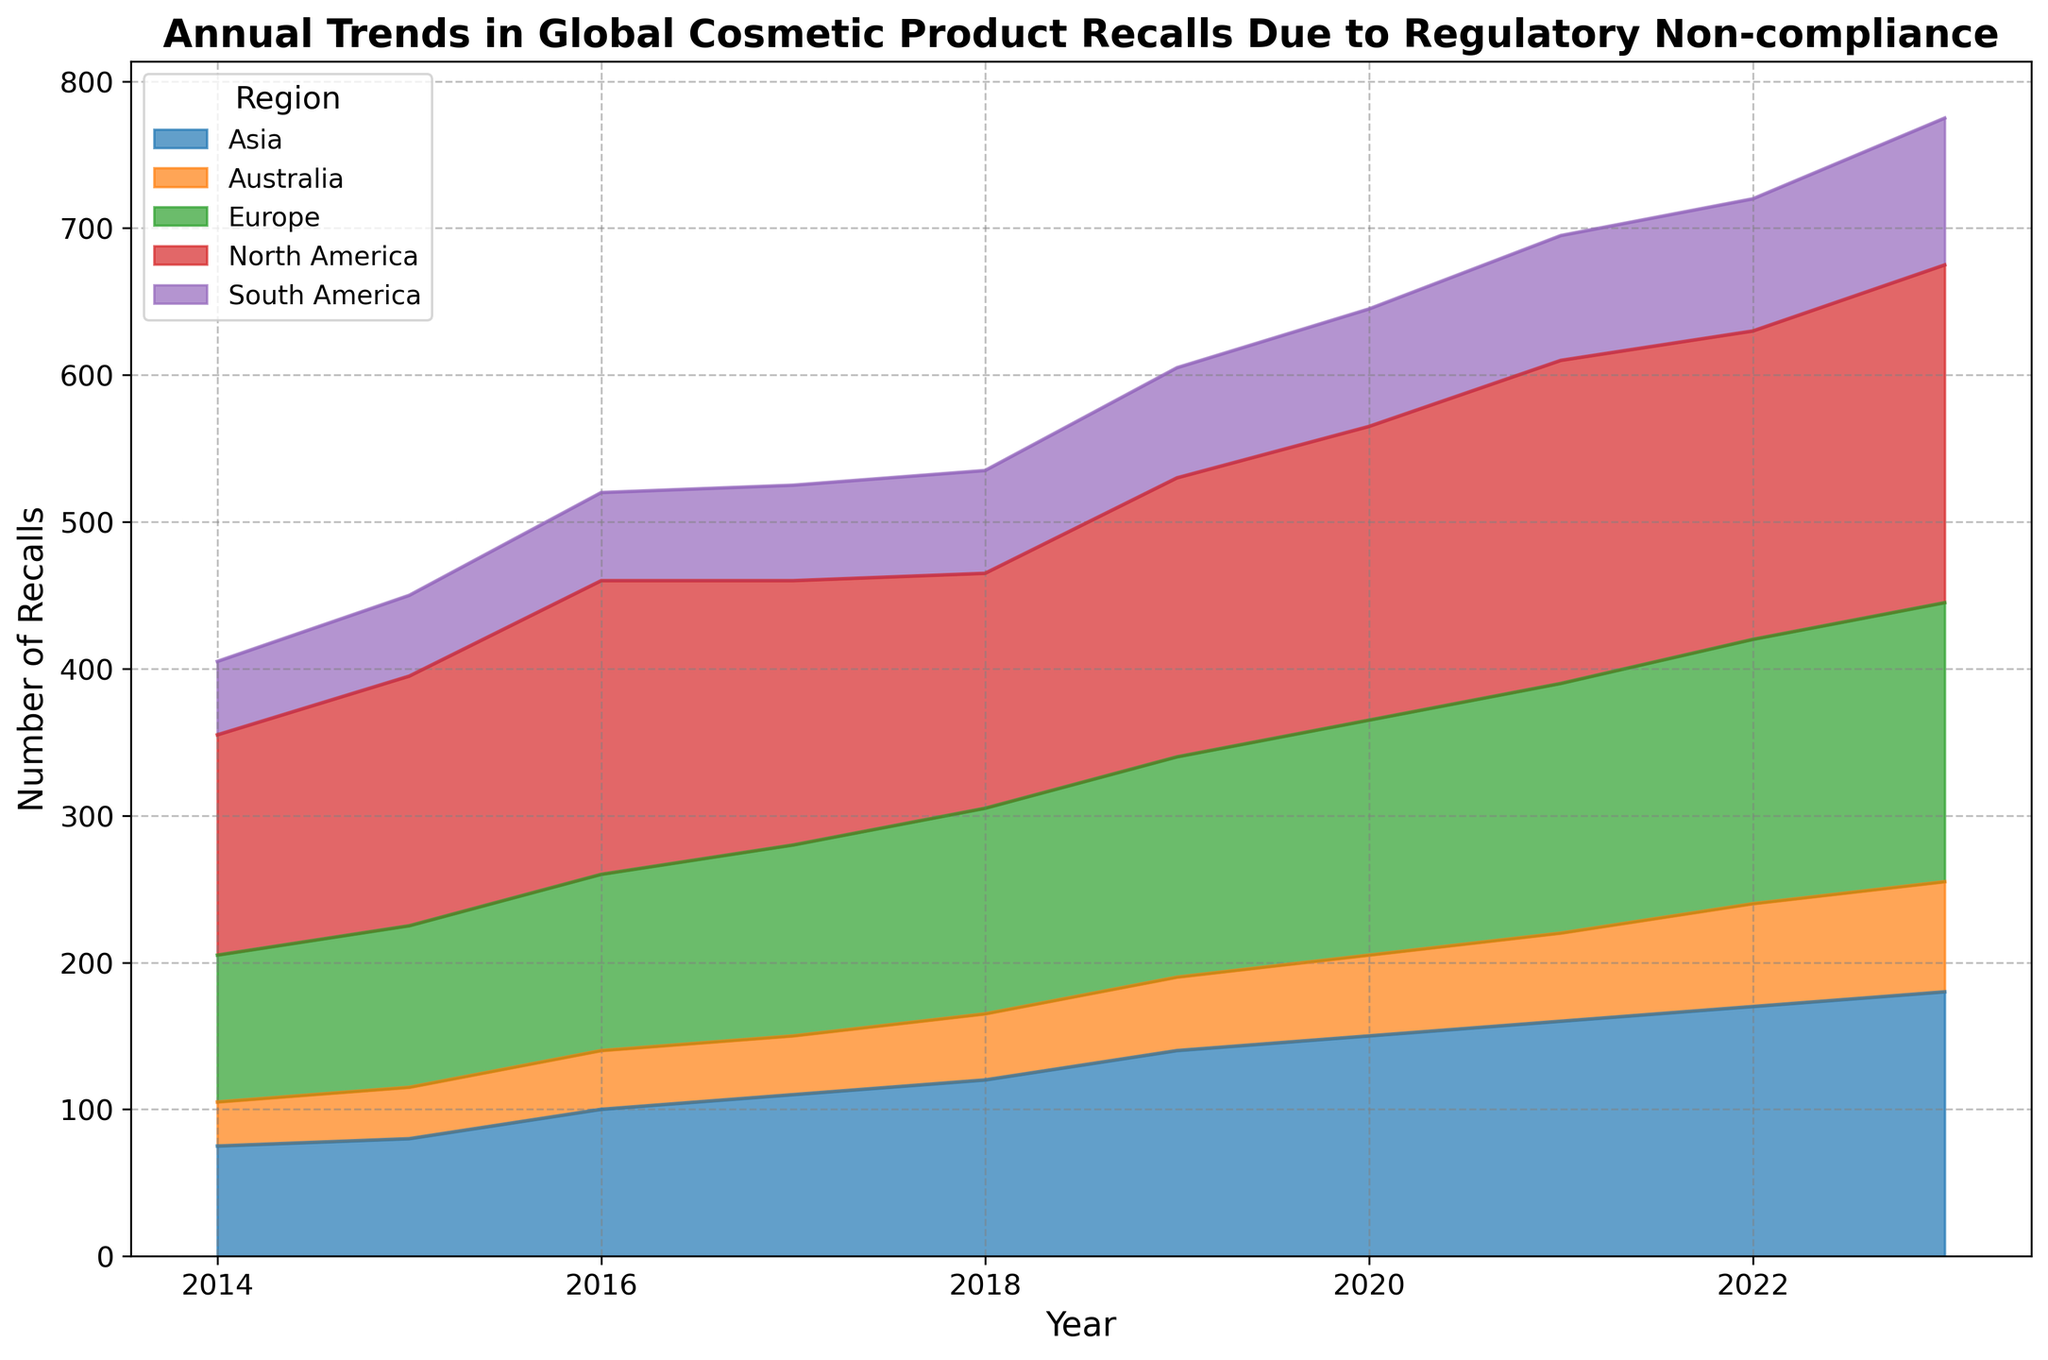When did North America experience the highest number of recalls? To determine the year with the highest number of recalls for North America, look at the height of the colored region corresponding to North America for each year and identify the peak. This occurs in 2023, noticeably higher compared to other years.
Answer: 2023 Which region saw the biggest increase in recalls from 2014 to 2023? To find this, calculate the difference in recalls between 2014 and 2023 for each region. For North America, it increased by 80 (230-150), Europe by 90 (190-100), Asia by 105 (180-75), South America by 50 (100-50), and Australia by 45 (75-30). Asia saw the biggest increase, 105.
Answer: Asia Across all regions, what is the combined total number of recalls in 2020? Sum the number of recalls for each region in 2020. North America: 200, Europe: 160, Asia: 150, South America: 80, Australia: 55. So, 200 + 160 + 150 + 80 + 55 = 645.
Answer: 645 Which region had the smallest number of recalls in 2018? Compare the values for 2018: North America (160), Europe (140), Asia (120), South America (70), Australia (45). Australia has the smallest value.
Answer: Australia What is the general trend for Europe in the number of recalls from 2014 to 2023? Observe the color band for Europe and notice its height's change over the years. The band generally increases from 100 in 2014 to 190 in 2023, showing a rising trend.
Answer: Increasing How did the number of recalls in South America change from 2016 to 2018? Compare the 2016 (60 recalls) and 2018 (70 recalls) values for South America. The number increased by 10 (70-60).
Answer: Increased What is the total number of recalls for Australia from 2014 to 2023? Sum the annual recalls for Australia over the years: 30+35+40+40+45+50+55+60+70+75 = 500.
Answer: 500 In which year did Asia experience the largest annual increase in recalls? Calculate the annual differences for Asia: 2015 (+5), 2016 (+20), 2017 (+10), 2018 (+10), 2019 (+20), 2020 (+10), 2021 (+10), 2022 (+10), 2023 (+10). The largest increase is from 2015 to 2016 (+20) and 2018 to 2019 (+20).
Answer: 2016 or 2019 Which two regions have the closest number of recalls in 2022? Compare the recalls for 2022: North America (210), Europe (180), Asia (170), South America (90), Australia (70). The closest are Europe (180) and Asia (170) with a difference of 10.
Answer: Europe and Asia 